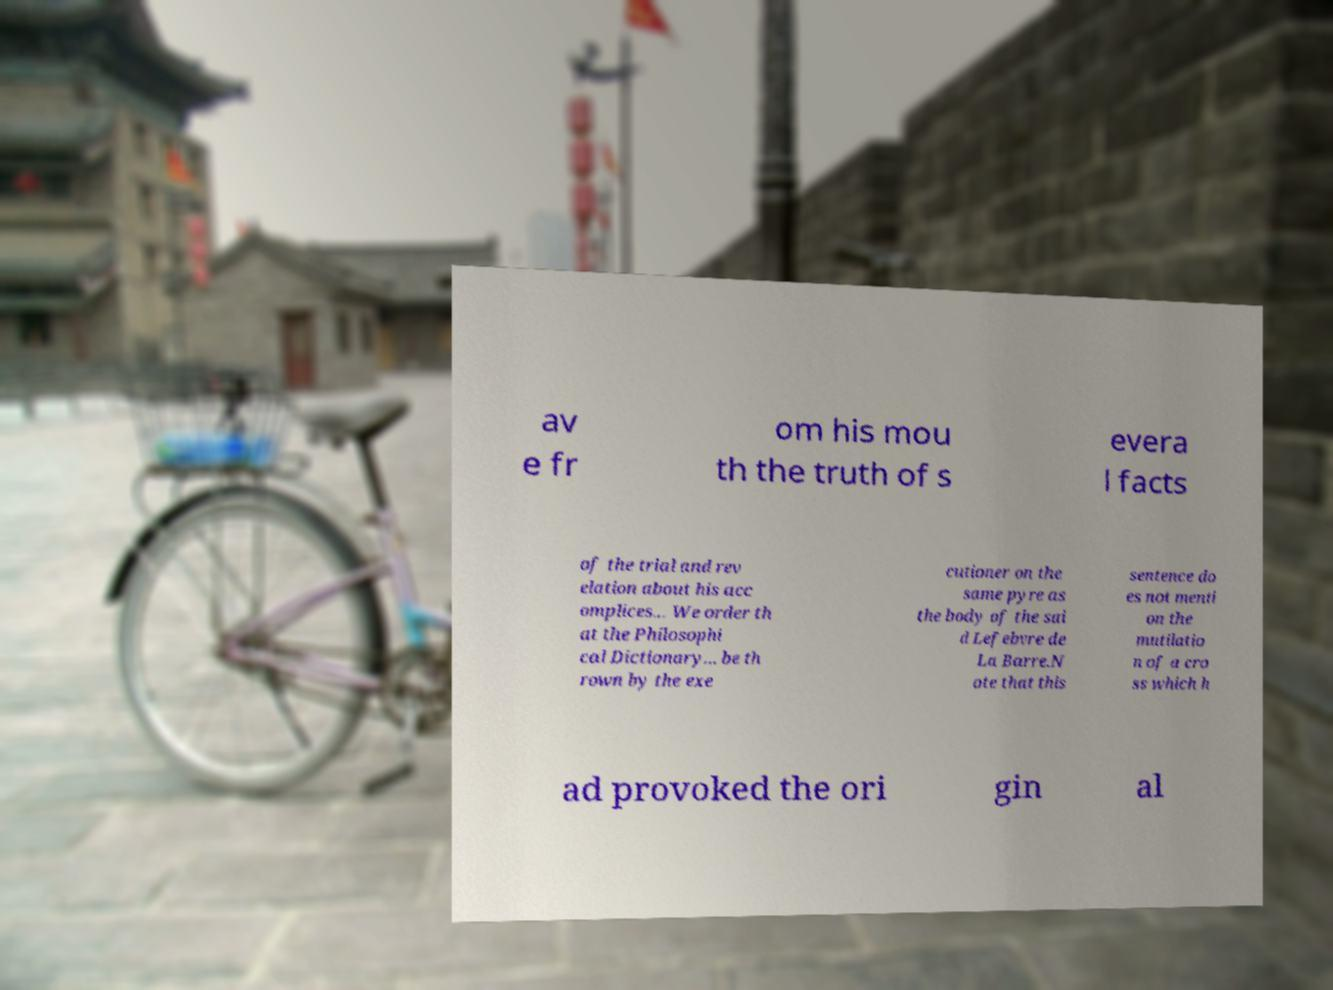I need the written content from this picture converted into text. Can you do that? av e fr om his mou th the truth of s evera l facts of the trial and rev elation about his acc omplices... We order th at the Philosophi cal Dictionary... be th rown by the exe cutioner on the same pyre as the body of the sai d Lefebvre de La Barre.N ote that this sentence do es not menti on the mutilatio n of a cro ss which h ad provoked the ori gin al 